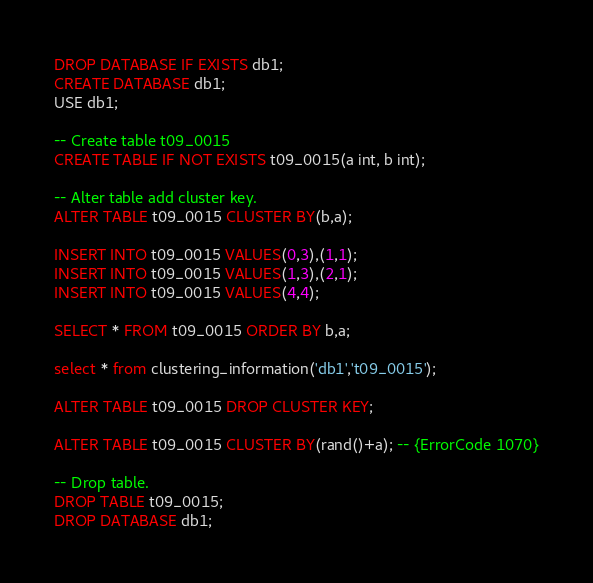Convert code to text. <code><loc_0><loc_0><loc_500><loc_500><_SQL_>DROP DATABASE IF EXISTS db1;
CREATE DATABASE db1;
USE db1;

-- Create table t09_0015
CREATE TABLE IF NOT EXISTS t09_0015(a int, b int);

-- Alter table add cluster key.
ALTER TABLE t09_0015 CLUSTER BY(b,a);

INSERT INTO t09_0015 VALUES(0,3),(1,1);
INSERT INTO t09_0015 VALUES(1,3),(2,1);
INSERT INTO t09_0015 VALUES(4,4);

SELECT * FROM t09_0015 ORDER BY b,a;

select * from clustering_information('db1','t09_0015');

ALTER TABLE t09_0015 DROP CLUSTER KEY;

ALTER TABLE t09_0015 CLUSTER BY(rand()+a); -- {ErrorCode 1070}

-- Drop table.
DROP TABLE t09_0015;
DROP DATABASE db1;
</code> 